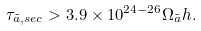Convert formula to latex. <formula><loc_0><loc_0><loc_500><loc_500>\tau _ { \tilde { a } , s e c } > 3 . 9 \times 1 0 ^ { 2 4 - 2 6 } \Omega _ { \tilde { a } } h .</formula> 